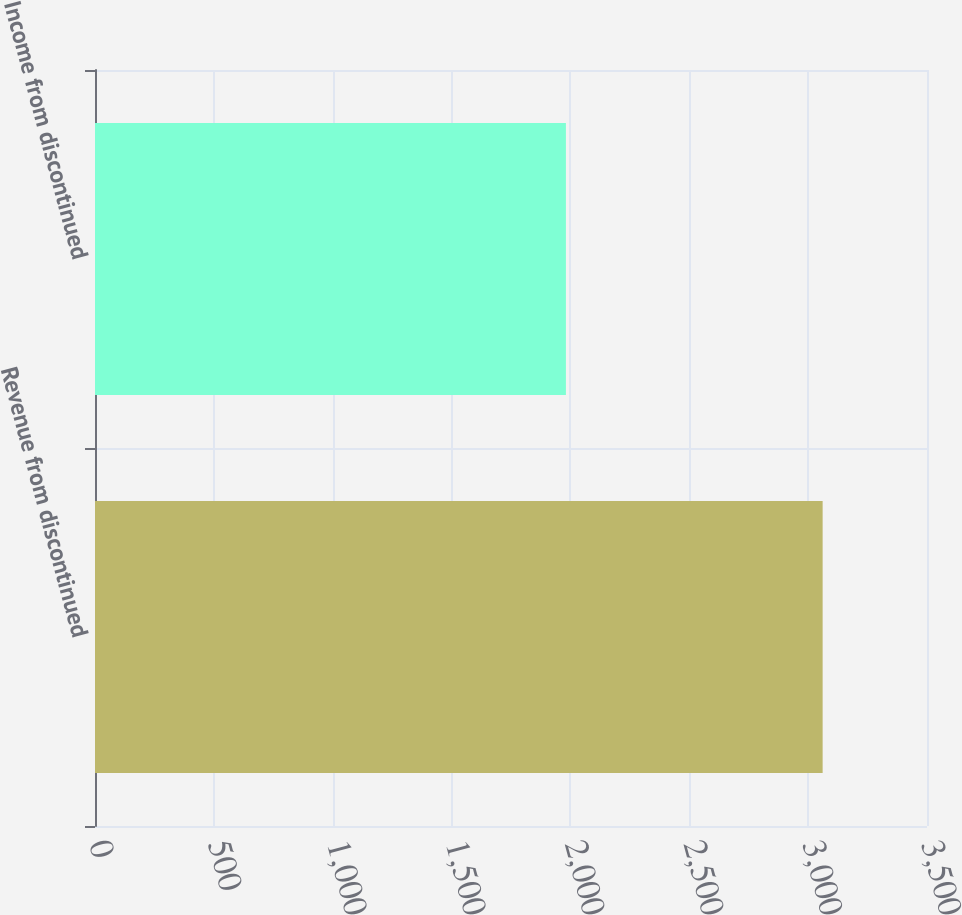<chart> <loc_0><loc_0><loc_500><loc_500><bar_chart><fcel>Revenue from discontinued<fcel>Income from discontinued<nl><fcel>3061<fcel>1981<nl></chart> 